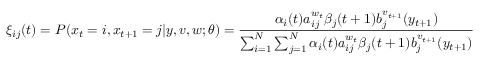Convert formula to latex. <formula><loc_0><loc_0><loc_500><loc_500>\xi _ { i j } ( t ) = P ( x _ { t } = i , x _ { t + 1 } = j | y , v , w ; \theta ) = { \frac { \alpha _ { i } ( t ) a _ { i j } ^ { w _ { t } } \beta _ { j } ( t + 1 ) b _ { j } ^ { v _ { t + 1 } } ( y _ { t + 1 } ) } { \sum _ { i = 1 } ^ { N } \sum _ { j = 1 } ^ { N } \alpha _ { i } ( t ) a _ { i j } ^ { w _ { t } } \beta _ { j } ( t + 1 ) b _ { j } ^ { v _ { t + 1 } } ( y _ { t + 1 } ) } }</formula> 